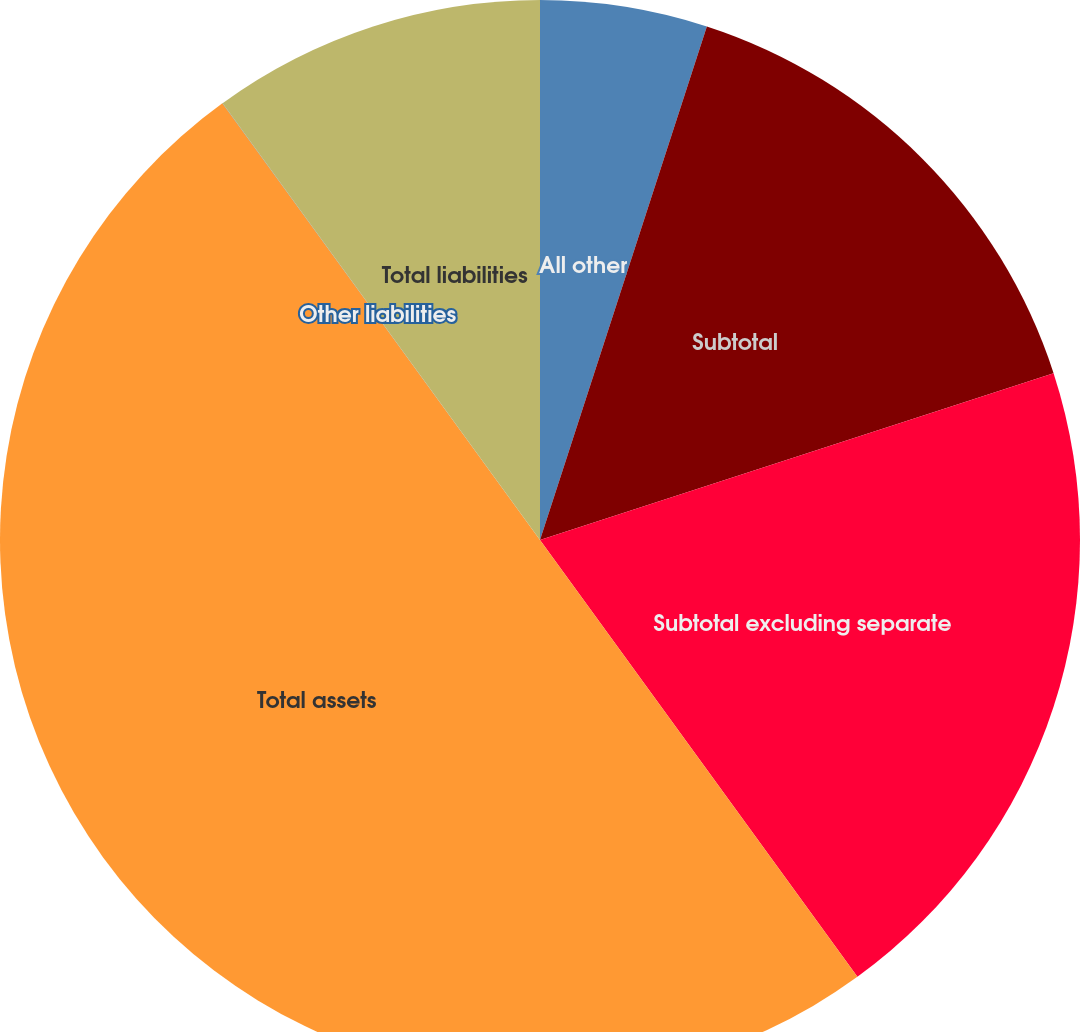<chart> <loc_0><loc_0><loc_500><loc_500><pie_chart><fcel>All other<fcel>Subtotal<fcel>Subtotal excluding separate<fcel>Total assets<fcel>Other liabilities<fcel>Total liabilities<nl><fcel>5.0%<fcel>15.0%<fcel>20.0%<fcel>49.99%<fcel>0.01%<fcel>10.0%<nl></chart> 